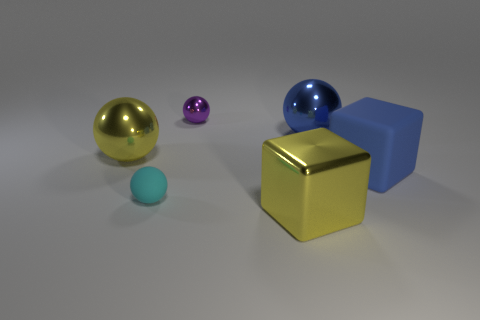There is a big yellow thing that is on the left side of the purple shiny thing; is it the same shape as the small metal object that is on the right side of the cyan ball?
Provide a succinct answer. Yes. There is a big cube behind the yellow thing that is in front of the matte ball; how many big shiny balls are right of it?
Keep it short and to the point. 0. What color is the small metallic object?
Provide a succinct answer. Purple. How many other things are the same size as the purple metal ball?
Make the answer very short. 1. What is the material of the other yellow thing that is the same shape as the tiny rubber thing?
Your answer should be very brief. Metal. What is the material of the yellow object right of the sphere behind the ball that is on the right side of the purple shiny object?
Ensure brevity in your answer.  Metal. There is a purple thing that is the same material as the big yellow sphere; what size is it?
Give a very brief answer. Small. Are there any other things that are the same color as the matte block?
Make the answer very short. Yes. There is a metal object that is right of the yellow shiny block; does it have the same color as the metal object in front of the blue rubber thing?
Give a very brief answer. No. The rubber object in front of the blue rubber cube is what color?
Provide a short and direct response. Cyan. 